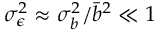Convert formula to latex. <formula><loc_0><loc_0><loc_500><loc_500>\sigma _ { \epsilon } ^ { 2 } \approx \sigma _ { b } ^ { 2 } / \bar { b } ^ { 2 } \ll 1</formula> 